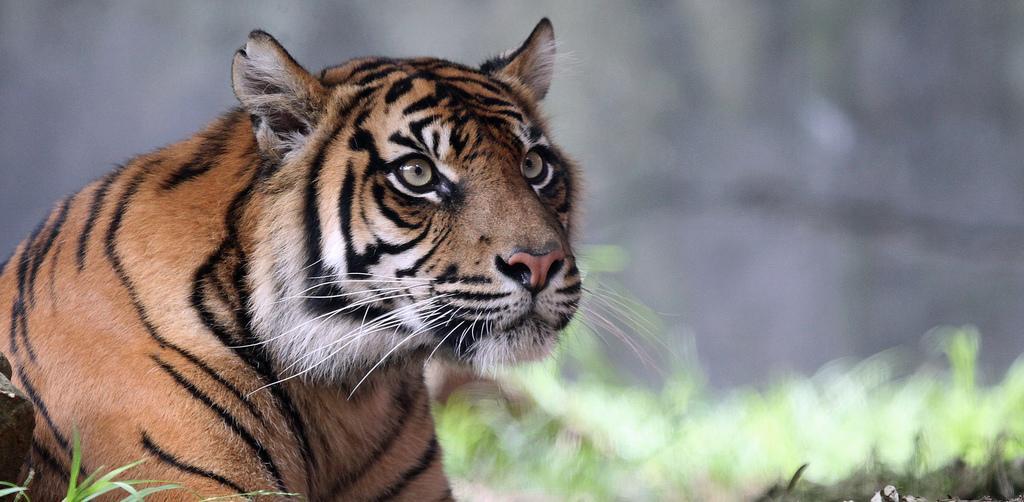Can you describe this image briefly? In this picture we can observe a tiger. We can observe some grass on the ground. The background is completely blurred. 